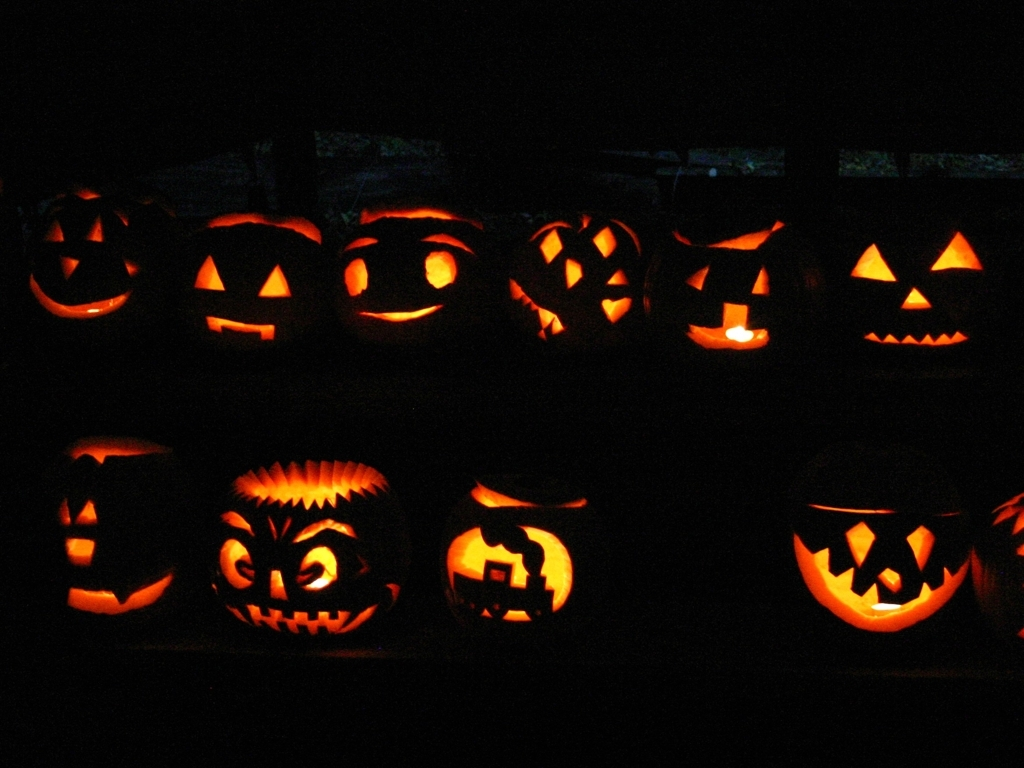Why do people carve pumpkins for Halloween? Carving pumpkins into jack-o'-lanterns is a popular Halloween tradition with roots in Irish folklore. Originally, lanterns were carved from turnips or potatoes to ward off evil spirits. When Irish immigrants arrived in America, they found pumpkins to be plentiful and ideal for carving, thus adopting them as the new symbol for this autumn holiday. 